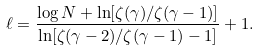Convert formula to latex. <formula><loc_0><loc_0><loc_500><loc_500>\ell = \frac { \log N + \ln [ \zeta ( \gamma ) / \zeta ( \gamma - 1 ) ] } { \ln [ \zeta ( \gamma - 2 ) / \zeta ( \gamma - 1 ) - 1 ] } + 1 .</formula> 